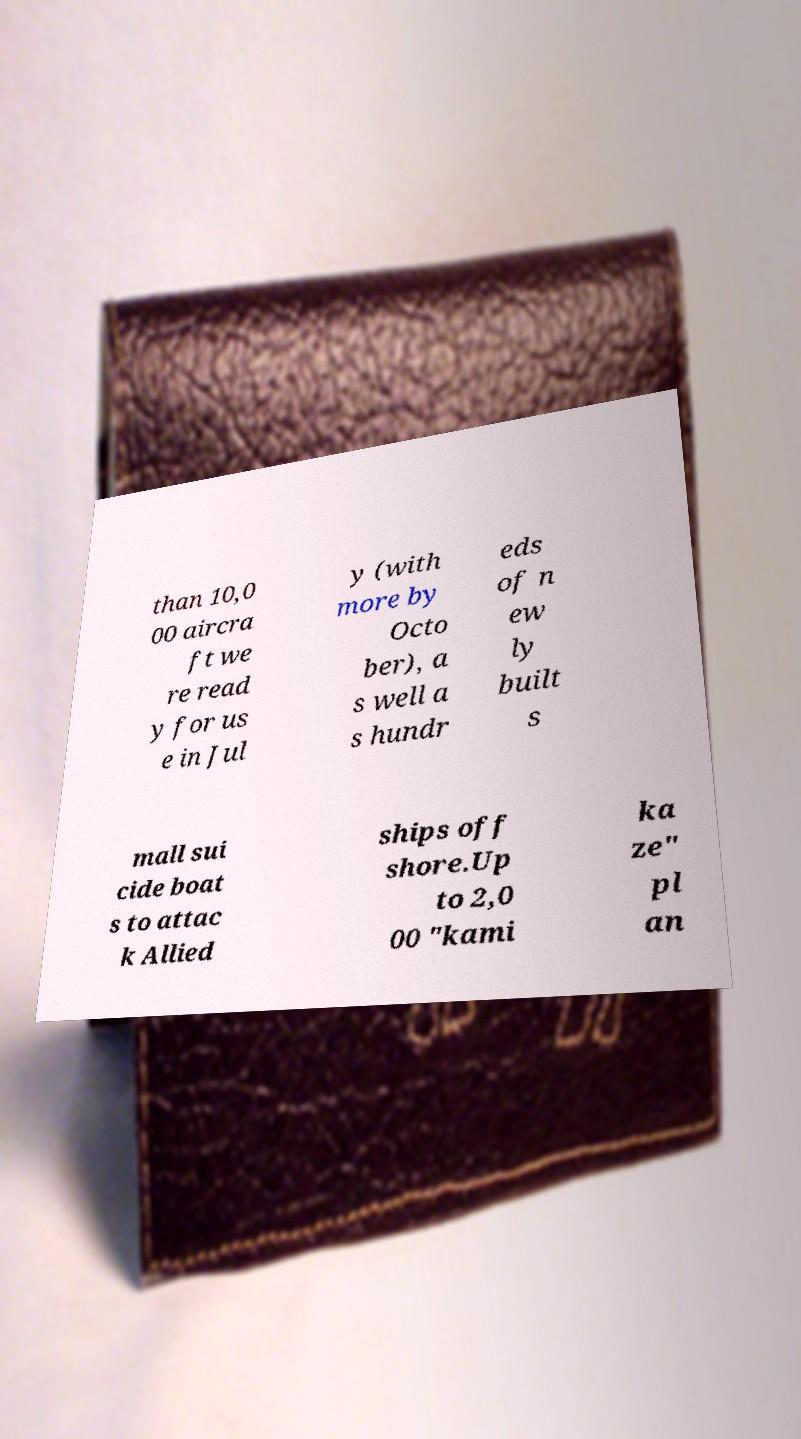Could you extract and type out the text from this image? than 10,0 00 aircra ft we re read y for us e in Jul y (with more by Octo ber), a s well a s hundr eds of n ew ly built s mall sui cide boat s to attac k Allied ships off shore.Up to 2,0 00 "kami ka ze" pl an 